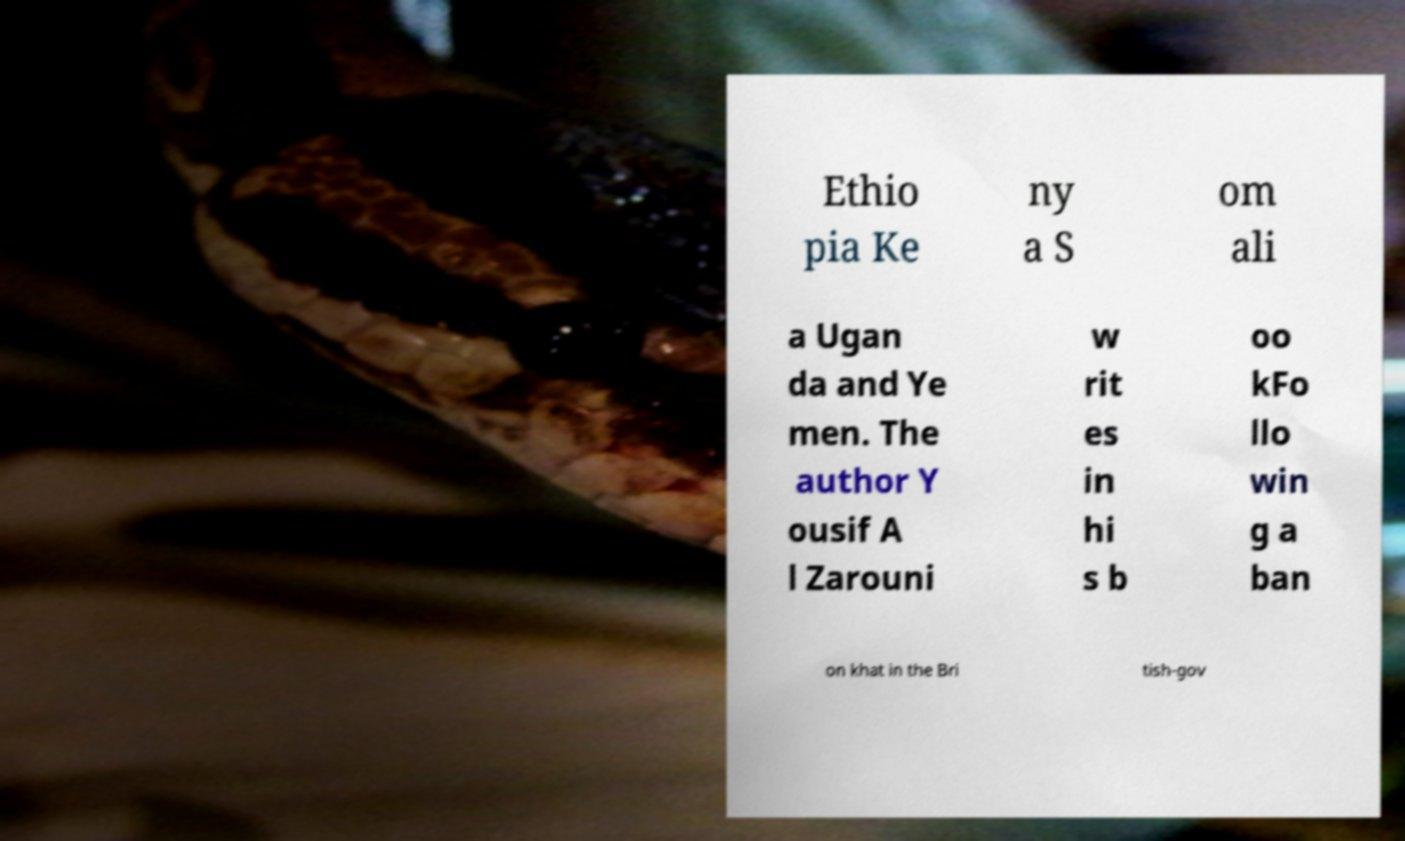Can you read and provide the text displayed in the image?This photo seems to have some interesting text. Can you extract and type it out for me? Ethio pia Ke ny a S om ali a Ugan da and Ye men. The author Y ousif A l Zarouni w rit es in hi s b oo kFo llo win g a ban on khat in the Bri tish-gov 